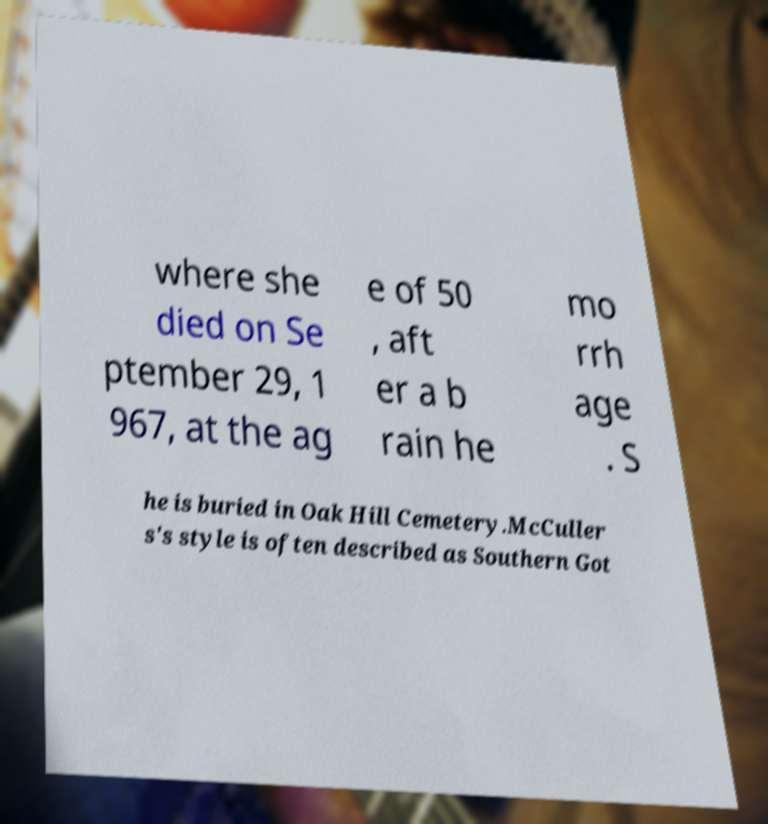Please identify and transcribe the text found in this image. where she died on Se ptember 29, 1 967, at the ag e of 50 , aft er a b rain he mo rrh age . S he is buried in Oak Hill Cemetery.McCuller s's style is often described as Southern Got 